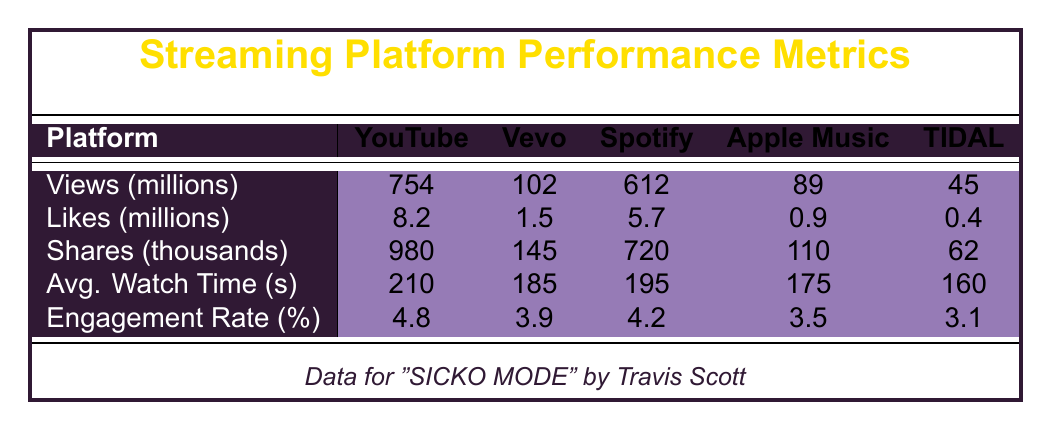What is the total number of views for "SICKO MODE" across all platforms? The views for "SICKO MODE" are: YouTube (754 million), Vevo (102 million), Spotify (612 million), Apple Music (89 million), and TIDAL (45 million). Adding them gives: 754 + 102 + 612 + 89 + 45 = 1602 million views.
Answer: 1602 million Which platform had the highest average watch time for "WAP"? For "WAP", the average watch times are: YouTube (230 seconds), Vevo (205 seconds), Spotify (215 seconds), Apple Music (190 seconds), and TIDAL (175 seconds). The highest number is 230 seconds on YouTube.
Answer: YouTube What is the difference in likes between the video "The Box" on YouTube and TIDAL? "The Box" received 5.9 million likes on YouTube and 0.2 million likes on TIDAL. The difference is 5.9 - 0.2 = 5.7 million likes.
Answer: 5.7 million Did "Laugh Now Cry Later" have more shares on YouTube or on Spotify? "Laugh Now Cry Later" had 580,000 shares on YouTube and 460,000 shares on Spotify. Since 580,000 > 460,000, the statement is true.
Answer: Yes What is the average engagement rate for all platforms for "FRANCHISE"? The engagement rates for "FRANCHISE" are: YouTube (4.1%), Vevo (3.5%), Spotify (3.8%), Apple Music (3.2%), and TIDAL (2.7%). The average is (4.1 + 3.5 + 3.8 + 3.2 + 2.7) / 5 = 3.666%, which rounds to approximately 3.7%.
Answer: 3.7% Which video had the lowest views on TIDAL? The views on TIDAL are: "SICKO MODE" (45 million), "WAP" (38 million), "The Box" (31 million), "FRANCHISE" (19 million), and "Laugh Now Cry Later" (26 million). "FRANCHISE" has the lowest at 19 million.
Answer: FRANCHISE How much higher were the likes on Spotify for "WAP" compared to Apple's Music? The likes for "WAP" are: Spotify (4.8 million) and Apple Music (0.8 million). The difference is 4.8 - 0.8 = 4 million.
Answer: 4 million Which platform had the highest number of shares for "SICKO MODE"? The shares for "SICKO MODE" on platforms are: YouTube (980 thousand), Vevo (145 thousand), Spotify (720 thousand), Apple Music (110 thousand), and TIDAL (62 thousand). YouTube has the highest with 980 thousand shares.
Answer: YouTube What is the total engagement rate for "Laugh Now Cry Later" across all platforms? The engagement rates are: YouTube (4.6%), Vevo (3.8%), Spotify (4.1%), Apple Music (3.5%), and TIDAL (3.0%). Adding these gives: 4.6 + 3.8 + 4.1 + 3.5 + 3.0 = 18.0%. The total engagement across platforms is then 18.0%.
Answer: 18.0% 